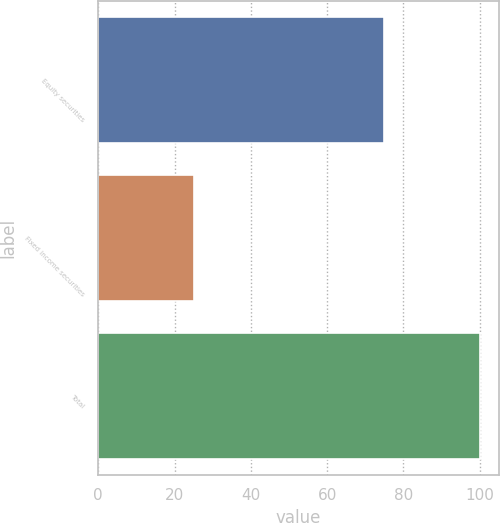<chart> <loc_0><loc_0><loc_500><loc_500><bar_chart><fcel>Equity securities<fcel>Fixed income securities<fcel>Total<nl><fcel>75<fcel>25<fcel>100<nl></chart> 